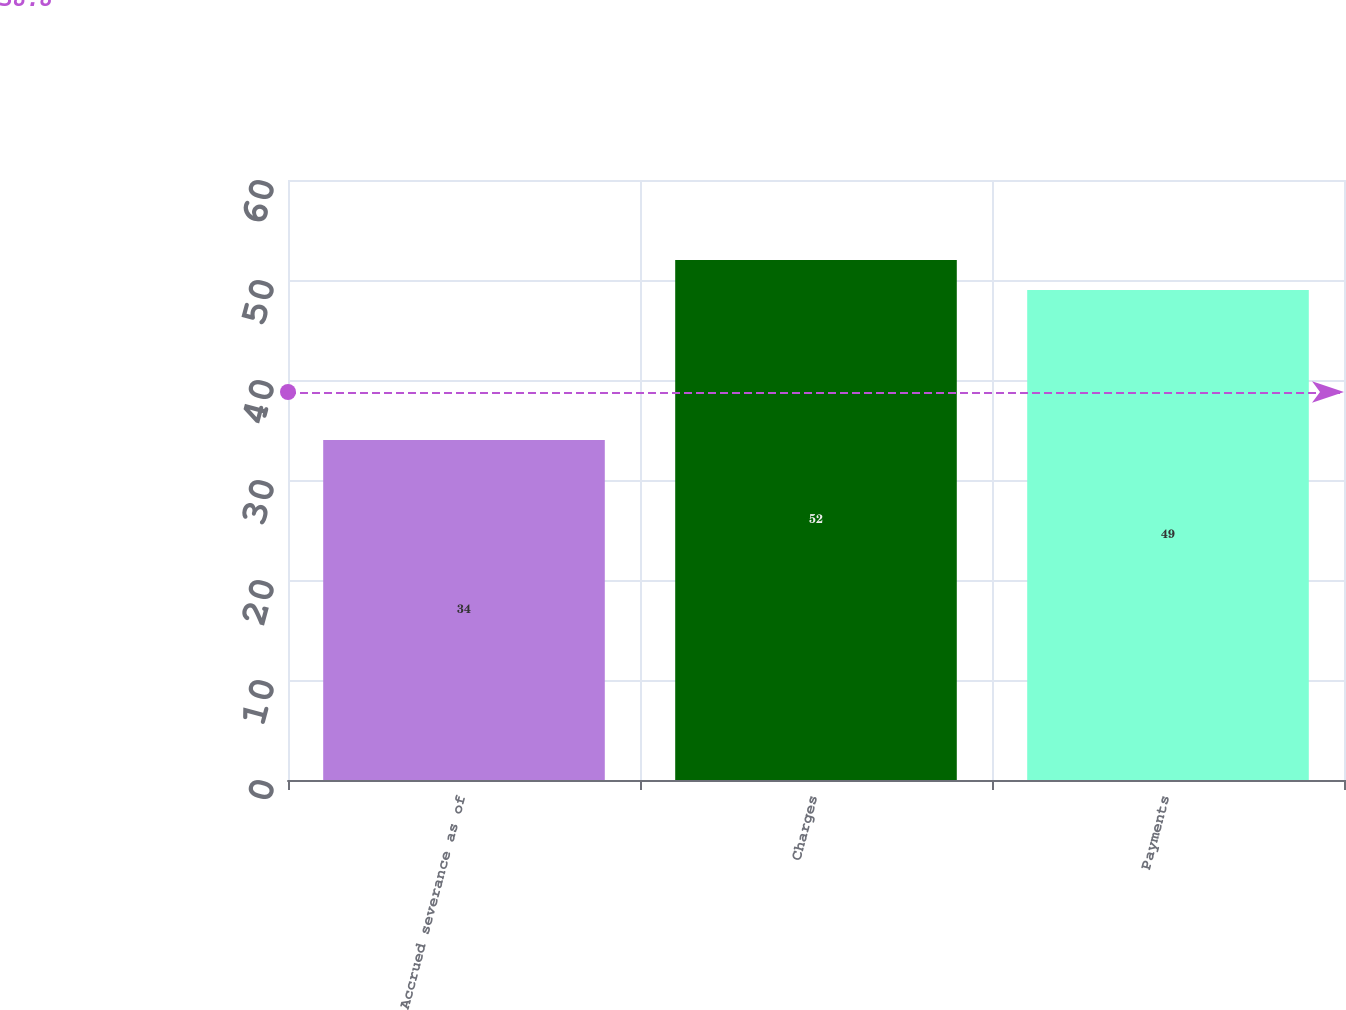<chart> <loc_0><loc_0><loc_500><loc_500><bar_chart><fcel>Accrued severance as of<fcel>Charges<fcel>Payments<nl><fcel>34<fcel>52<fcel>49<nl></chart> 